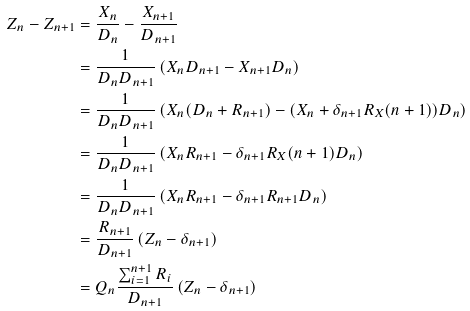<formula> <loc_0><loc_0><loc_500><loc_500>Z _ { n } - Z _ { n + 1 } & = \frac { X _ { n } } { D _ { n } } - \frac { X _ { n + 1 } } { D _ { n + 1 } } \\ & = \frac { 1 } { D _ { n } D _ { n + 1 } } \left ( X _ { n } D _ { n + 1 } - X _ { n + 1 } D _ { n } \right ) \\ & = \frac { 1 } { D _ { n } D _ { n + 1 } } \left ( X _ { n } ( D _ { n } + { { R _ { n + 1 } } } ) - ( X _ { n } + \delta _ { n + 1 } R _ { X } ( n + 1 ) ) D _ { n } \right ) \\ & = \frac { 1 } { D _ { n } D _ { n + 1 } } \left ( X _ { n } { { R _ { n + 1 } } } - \delta _ { n + 1 } R _ { X } ( n + 1 ) D _ { n } \right ) \\ & = \frac { 1 } { D _ { n } D _ { n + 1 } } \left ( X _ { n } { { R _ { n + 1 } } } - \delta _ { n + 1 } { { R _ { n + 1 } } } D _ { n } \right ) \\ & = \frac { { { R _ { n + 1 } } } } { D _ { n + 1 } } \left ( Z _ { n } - \delta _ { n + 1 } \right ) \\ & = Q _ { n } \frac { \sum _ { i = 1 } ^ { n + 1 } R _ { i } } { D _ { n + 1 } } \left ( Z _ { n } - \delta _ { n + 1 } \right )</formula> 